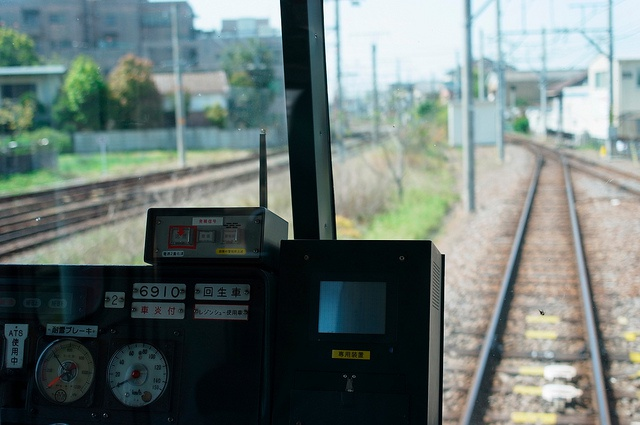Describe the objects in this image and their specific colors. I can see various objects in this image with different colors. 